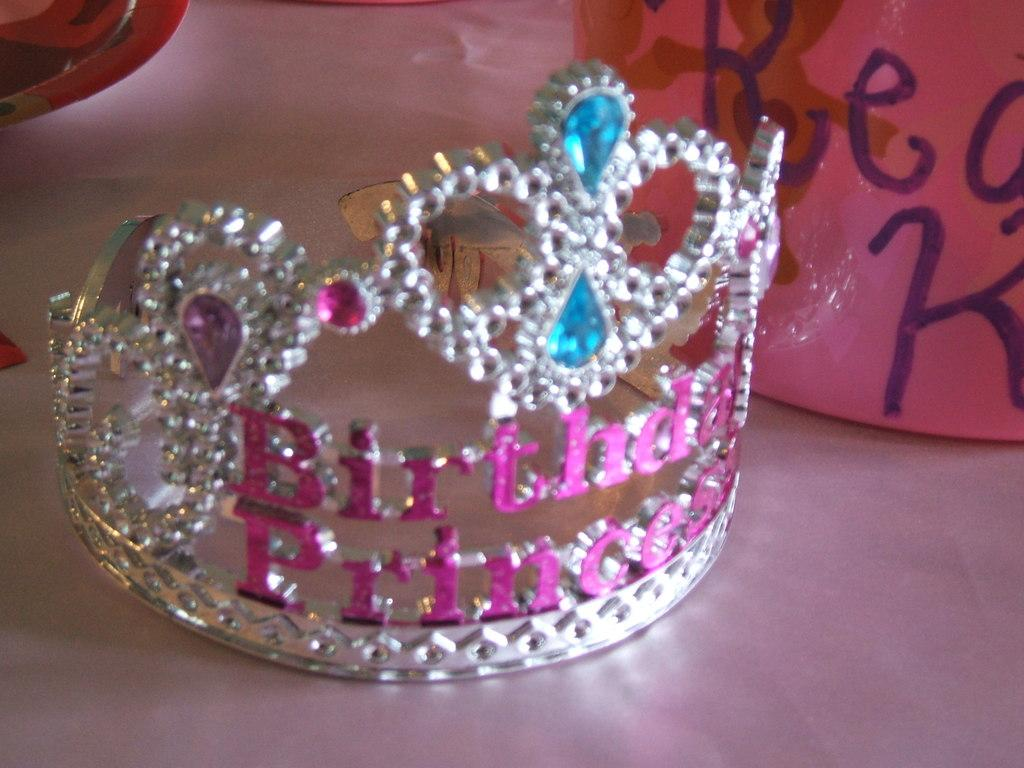What type of furniture is present in the image? There is a table in the image. What objects are on the table? There is a crown and a balloon on the table. Is there any other object on the table besides the crown and balloon? Yes, there is an unspecified object on the table. What type of industry can be seen in the background of the image? There is no industry visible in the image; it only shows a table with objects on it. 